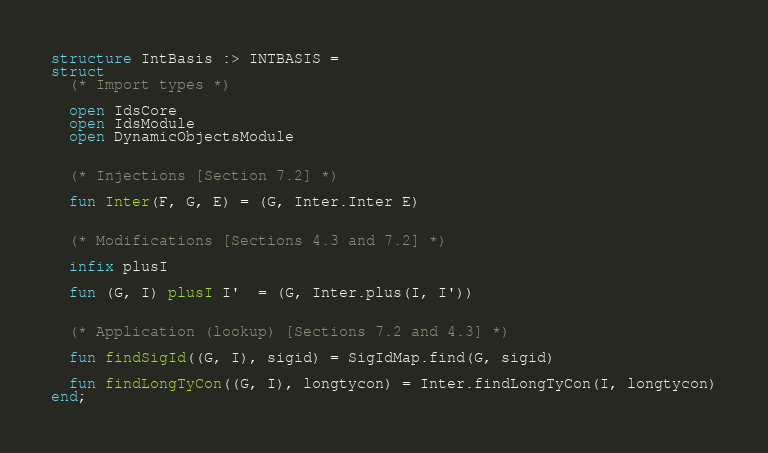Convert code to text. <code><loc_0><loc_0><loc_500><loc_500><_SML_>structure IntBasis :> INTBASIS =
struct
  (* Import types *)

  open IdsCore
  open IdsModule
  open DynamicObjectsModule


  (* Injections [Section 7.2] *)

  fun Inter(F, G, E) = (G, Inter.Inter E)


  (* Modifications [Sections 4.3 and 7.2] *)

  infix plusI

  fun (G, I) plusI I'  = (G, Inter.plus(I, I'))


  (* Application (lookup) [Sections 7.2 and 4.3] *)

  fun findSigId((G, I), sigid) = SigIdMap.find(G, sigid)

  fun findLongTyCon((G, I), longtycon) = Inter.findLongTyCon(I, longtycon)
end;
</code> 